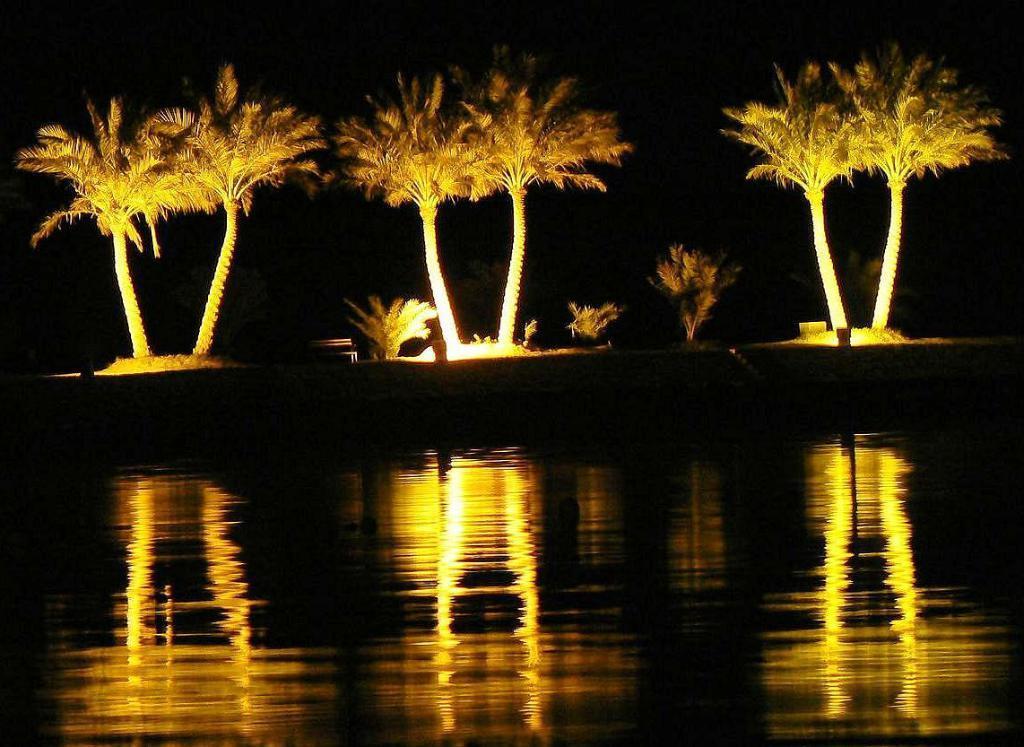Can you describe this image briefly? In the foreground of this image, there are trees and plants placed side to a river and this picture is taken in the dark. 